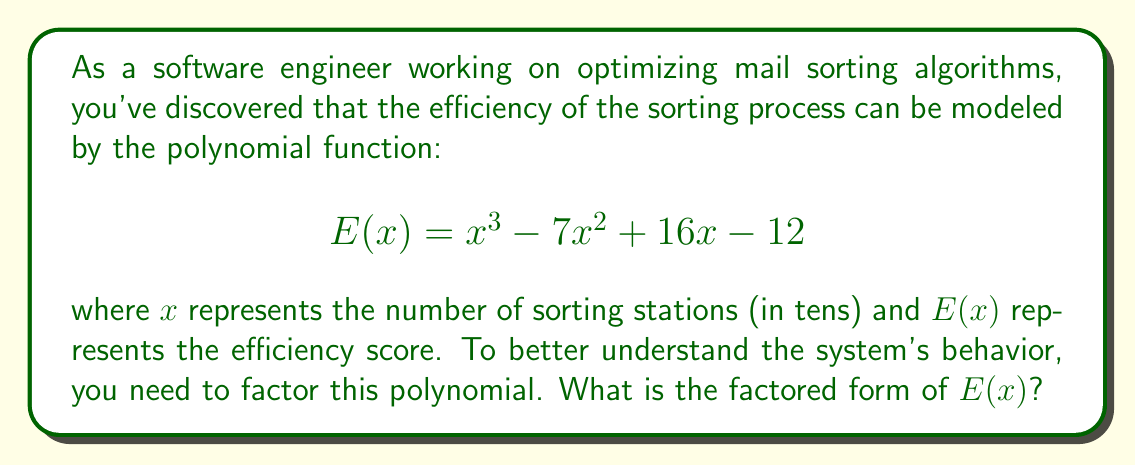Give your solution to this math problem. To factor this polynomial, we'll follow these steps:

1) First, let's check if there are any common factors. In this case, there are none.

2) Next, we'll try to guess one of the factors. Since the constant term is -12, possible factors could be ±1, ±2, ±3, ±4, ±6, ±12. Let's try these in the polynomial:

   $E(1) = 1 - 7 + 16 - 12 = -2$
   $E(2) = 8 - 28 + 32 - 12 = 0$

   We've found that $(x-2)$ is a factor.

3) Now we can divide $E(x)$ by $(x-2)$ to get the other factor:

   $$\frac{x^3 - 7x^2 + 16x - 12}{x-2} = x^2 - 5x + 6$$

4) The quadratic factor $x^2 - 5x + 6$ can be further factored:
   
   $$(x-2)(x-3)$$

5) Therefore, the complete factorization is:

   $$E(x) = (x-2)(x-2)(x-3)$$

   Or, more concisely:

   $$E(x) = (x-2)^2(x-3)$$

This factorization reveals that the efficiency function has roots at $x=2$ (a double root) and $x=3$, corresponding to 20 and 30 sorting stations respectively.
Answer: $E(x) = (x-2)^2(x-3)$ 